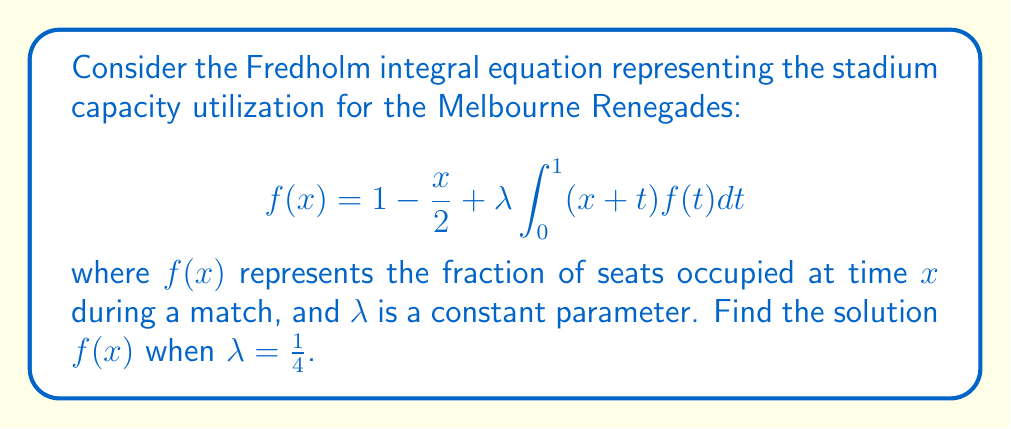Help me with this question. Let's solve this step-by-step:

1) We assume a solution of the form $f(x) = a + bx$, where $a$ and $b$ are constants to be determined.

2) Substitute this into the right-hand side of the equation:

   $$1 - \frac{x}{2} + \frac{1}{4} \int_0^1 (x+t)(a + bt)dt$$

3) Evaluate the integral:

   $$1 - \frac{x}{2} + \frac{1}{4} \left[ax + \frac{a}{2} + \frac{bx}{2} + \frac{b}{3}\right]$$

4) Simplify:

   $$1 - \frac{x}{2} + \frac{ax}{4} + \frac{a}{8} + \frac{bx}{8} + \frac{b}{12}$$

5) This should equal $a + bx$. Equate coefficients:

   Constant terms: $1 + \frac{a}{8} + \frac{b}{12} = a$
   $x$ terms: $-\frac{1}{2} + \frac{a}{4} + \frac{b}{8} = b$

6) Solve these equations:

   From the first equation: $a = \frac{24}{23}$
   Substituting into the second: $b = -\frac{4}{23}$

7) Therefore, the solution is:

   $$f(x) = \frac{24}{23} - \frac{4}{23}x$$
Answer: $f(x) = \frac{24}{23} - \frac{4}{23}x$ 